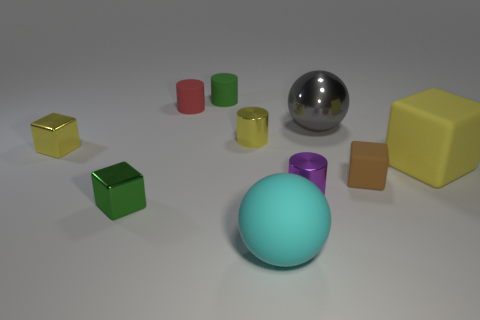Subtract all balls. How many objects are left? 8 Subtract 0 brown cylinders. How many objects are left? 10 Subtract all yellow shiny balls. Subtract all small metallic objects. How many objects are left? 6 Add 7 spheres. How many spheres are left? 9 Add 6 blue matte spheres. How many blue matte spheres exist? 6 